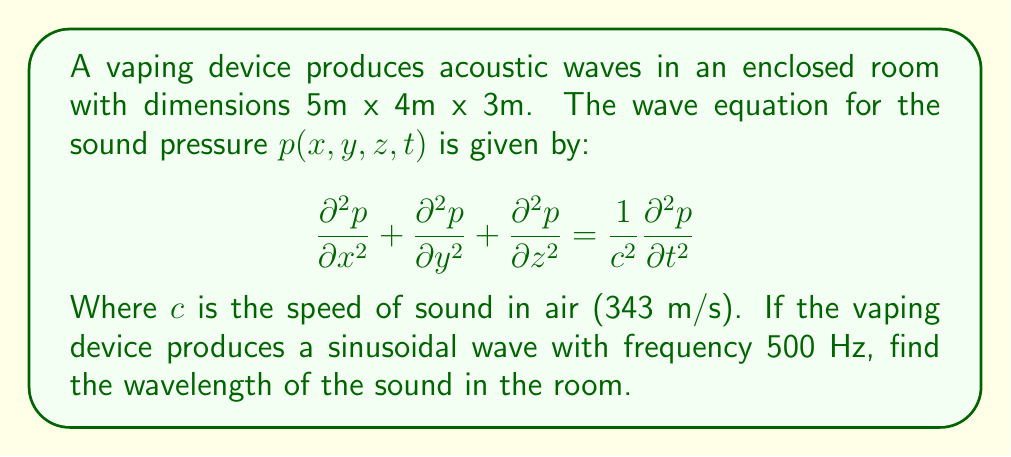Give your solution to this math problem. To solve this problem, we'll follow these steps:

1) The wave equation relates the spatial derivatives of pressure to its time derivative. For a sinusoidal wave, we can assume a solution of the form:

   $$p(x,y,z,t) = A\sin(kx - \omega t)$$

   Where $k$ is the wave number and $\omega$ is the angular frequency.

2) We know that $\omega = 2\pi f$, where $f$ is the frequency. Given $f = 500$ Hz:

   $$\omega = 2\pi(500) = 1000\pi \text{ rad/s}$$

3) The speed of a wave is related to its frequency and wavelength by:

   $$c = f\lambda$$

   Where $\lambda$ is the wavelength.

4) Rearranging this equation:

   $$\lambda = \frac{c}{f}$$

5) Substituting the known values:

   $$\lambda = \frac{343 \text{ m/s}}{500 \text{ Hz}} = 0.686 \text{ m}$$

6) We can verify this by calculating the wave number $k$:

   $$k = \frac{2\pi}{\lambda} = \frac{2\pi}{0.686} \approx 9.16 \text{ m}^{-1}$$

   And confirming that $\omega = ck$:

   $$ck = 343 * 9.16 \approx 3141.88 \text{ rad/s} \approx 1000\pi \text{ rad/s} = \omega$$

Thus, the wavelength of the sound in the room is approximately 0.686 meters.
Answer: 0.686 m 